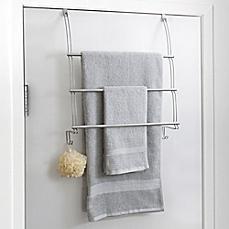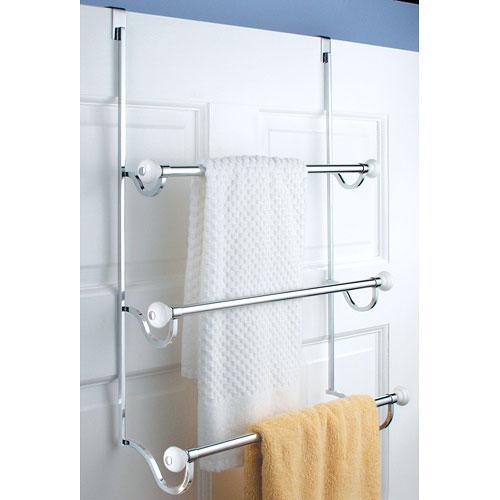The first image is the image on the left, the second image is the image on the right. Analyze the images presented: Is the assertion "An image shows a light blue towel hanging on an over-the-door rack." valid? Answer yes or no. No. The first image is the image on the left, the second image is the image on the right. Analyze the images presented: Is the assertion "There is a blue towel hanging on an over the door rack" valid? Answer yes or no. No. 